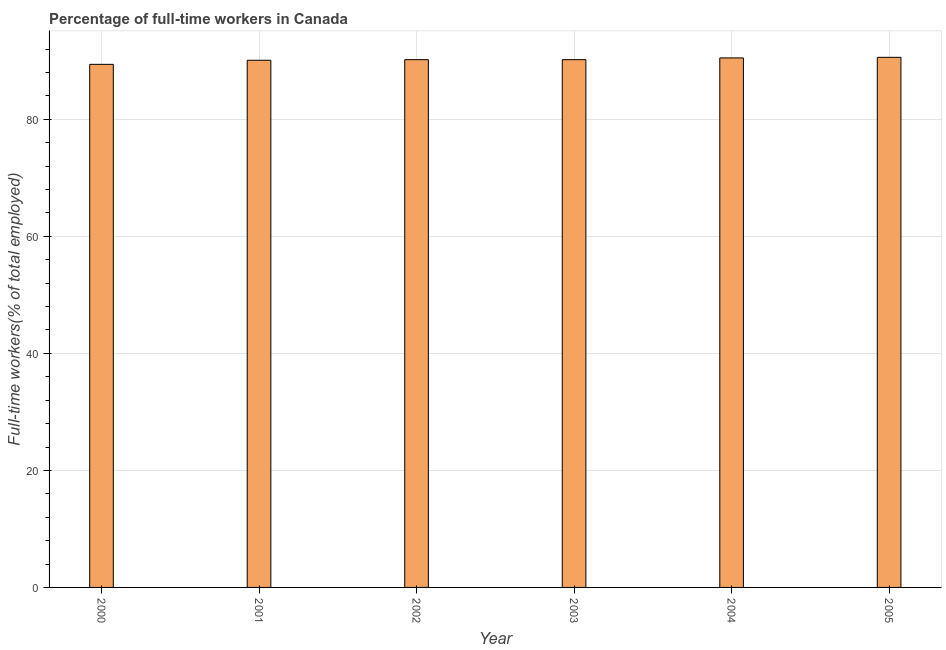Does the graph contain any zero values?
Your answer should be compact. No. Does the graph contain grids?
Offer a terse response. Yes. What is the title of the graph?
Offer a very short reply. Percentage of full-time workers in Canada. What is the label or title of the Y-axis?
Make the answer very short. Full-time workers(% of total employed). What is the percentage of full-time workers in 2003?
Provide a short and direct response. 90.2. Across all years, what is the maximum percentage of full-time workers?
Provide a short and direct response. 90.6. Across all years, what is the minimum percentage of full-time workers?
Keep it short and to the point. 89.4. In which year was the percentage of full-time workers maximum?
Your response must be concise. 2005. In which year was the percentage of full-time workers minimum?
Offer a very short reply. 2000. What is the sum of the percentage of full-time workers?
Keep it short and to the point. 541. What is the difference between the percentage of full-time workers in 2001 and 2002?
Offer a very short reply. -0.1. What is the average percentage of full-time workers per year?
Give a very brief answer. 90.17. What is the median percentage of full-time workers?
Make the answer very short. 90.2. In how many years, is the percentage of full-time workers greater than 8 %?
Your answer should be very brief. 6. What is the ratio of the percentage of full-time workers in 2000 to that in 2005?
Keep it short and to the point. 0.99. What is the difference between the highest and the second highest percentage of full-time workers?
Offer a very short reply. 0.1. What is the difference between the highest and the lowest percentage of full-time workers?
Provide a short and direct response. 1.2. In how many years, is the percentage of full-time workers greater than the average percentage of full-time workers taken over all years?
Your response must be concise. 4. Are all the bars in the graph horizontal?
Your answer should be very brief. No. How many years are there in the graph?
Your answer should be very brief. 6. What is the difference between two consecutive major ticks on the Y-axis?
Make the answer very short. 20. Are the values on the major ticks of Y-axis written in scientific E-notation?
Provide a short and direct response. No. What is the Full-time workers(% of total employed) in 2000?
Your answer should be compact. 89.4. What is the Full-time workers(% of total employed) of 2001?
Provide a succinct answer. 90.1. What is the Full-time workers(% of total employed) of 2002?
Ensure brevity in your answer.  90.2. What is the Full-time workers(% of total employed) in 2003?
Ensure brevity in your answer.  90.2. What is the Full-time workers(% of total employed) in 2004?
Your response must be concise. 90.5. What is the Full-time workers(% of total employed) in 2005?
Give a very brief answer. 90.6. What is the difference between the Full-time workers(% of total employed) in 2000 and 2001?
Your response must be concise. -0.7. What is the difference between the Full-time workers(% of total employed) in 2000 and 2002?
Ensure brevity in your answer.  -0.8. What is the difference between the Full-time workers(% of total employed) in 2000 and 2003?
Your answer should be compact. -0.8. What is the difference between the Full-time workers(% of total employed) in 2000 and 2004?
Make the answer very short. -1.1. What is the difference between the Full-time workers(% of total employed) in 2002 and 2004?
Provide a succinct answer. -0.3. What is the difference between the Full-time workers(% of total employed) in 2003 and 2004?
Keep it short and to the point. -0.3. What is the ratio of the Full-time workers(% of total employed) in 2000 to that in 2001?
Ensure brevity in your answer.  0.99. What is the ratio of the Full-time workers(% of total employed) in 2000 to that in 2003?
Offer a terse response. 0.99. What is the ratio of the Full-time workers(% of total employed) in 2001 to that in 2002?
Your answer should be very brief. 1. What is the ratio of the Full-time workers(% of total employed) in 2001 to that in 2003?
Your answer should be compact. 1. What is the ratio of the Full-time workers(% of total employed) in 2001 to that in 2005?
Provide a short and direct response. 0.99. What is the ratio of the Full-time workers(% of total employed) in 2002 to that in 2003?
Offer a very short reply. 1. What is the ratio of the Full-time workers(% of total employed) in 2002 to that in 2005?
Offer a very short reply. 1. What is the ratio of the Full-time workers(% of total employed) in 2003 to that in 2004?
Provide a succinct answer. 1. 